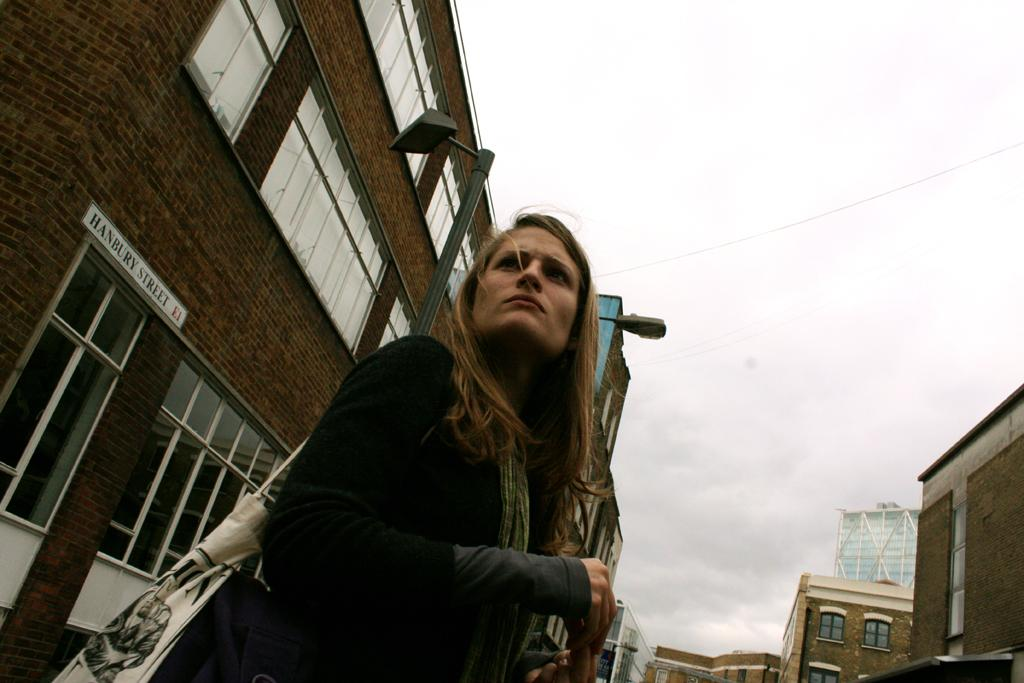What is the main subject in the foreground of the image? There is a woman standing in the foreground of the image. What is the woman wearing in the image? The woman is wearing a bag in the image. What can be seen in the background of the image? There are buildings, light poles, clouds, and the sky visible in the background of the image. What type of pickle is on the floor in the image? There is no pickle present in the image; the floor is not mentioned in the provided facts. 